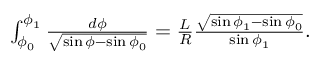Convert formula to latex. <formula><loc_0><loc_0><loc_500><loc_500>\begin{array} { r } { \int _ { \phi _ { 0 } } ^ { \phi _ { 1 } } \frac { d \phi } { \sqrt { \sin \phi - \sin \phi _ { 0 } } } = \frac { L } { R } \frac { \sqrt { \sin \phi _ { 1 } - \sin \phi _ { 0 } } } { \sin \phi _ { 1 } } . } \end{array}</formula> 